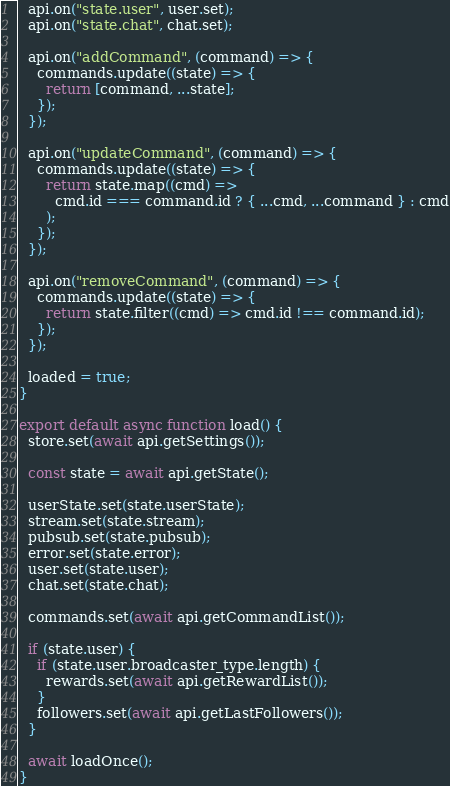<code> <loc_0><loc_0><loc_500><loc_500><_JavaScript_>  api.on("state.user", user.set);
  api.on("state.chat", chat.set);

  api.on("addCommand", (command) => {
    commands.update((state) => {
      return [command, ...state];
    });
  });

  api.on("updateCommand", (command) => {
    commands.update((state) => {
      return state.map((cmd) =>
        cmd.id === command.id ? { ...cmd, ...command } : cmd
      );
    });
  });

  api.on("removeCommand", (command) => {
    commands.update((state) => {
      return state.filter((cmd) => cmd.id !== command.id);
    });
  });

  loaded = true;
}

export default async function load() {
  store.set(await api.getSettings());

  const state = await api.getState();

  userState.set(state.userState);
  stream.set(state.stream);
  pubsub.set(state.pubsub);
  error.set(state.error);
  user.set(state.user);
  chat.set(state.chat);

  commands.set(await api.getCommandList());

  if (state.user) {
    if (state.user.broadcaster_type.length) {
      rewards.set(await api.getRewardList());
    }
    followers.set(await api.getLastFollowers());
  }

  await loadOnce();
}
</code> 